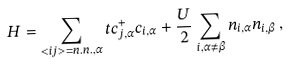Convert formula to latex. <formula><loc_0><loc_0><loc_500><loc_500>H = \sum _ { < i j > = n . n . , \alpha } t c _ { j , \alpha } ^ { + } c _ { i , \alpha } + \frac { U } { 2 } \sum _ { i , \alpha \ne \beta } n _ { i , \alpha } n _ { i , \beta } \, ,</formula> 